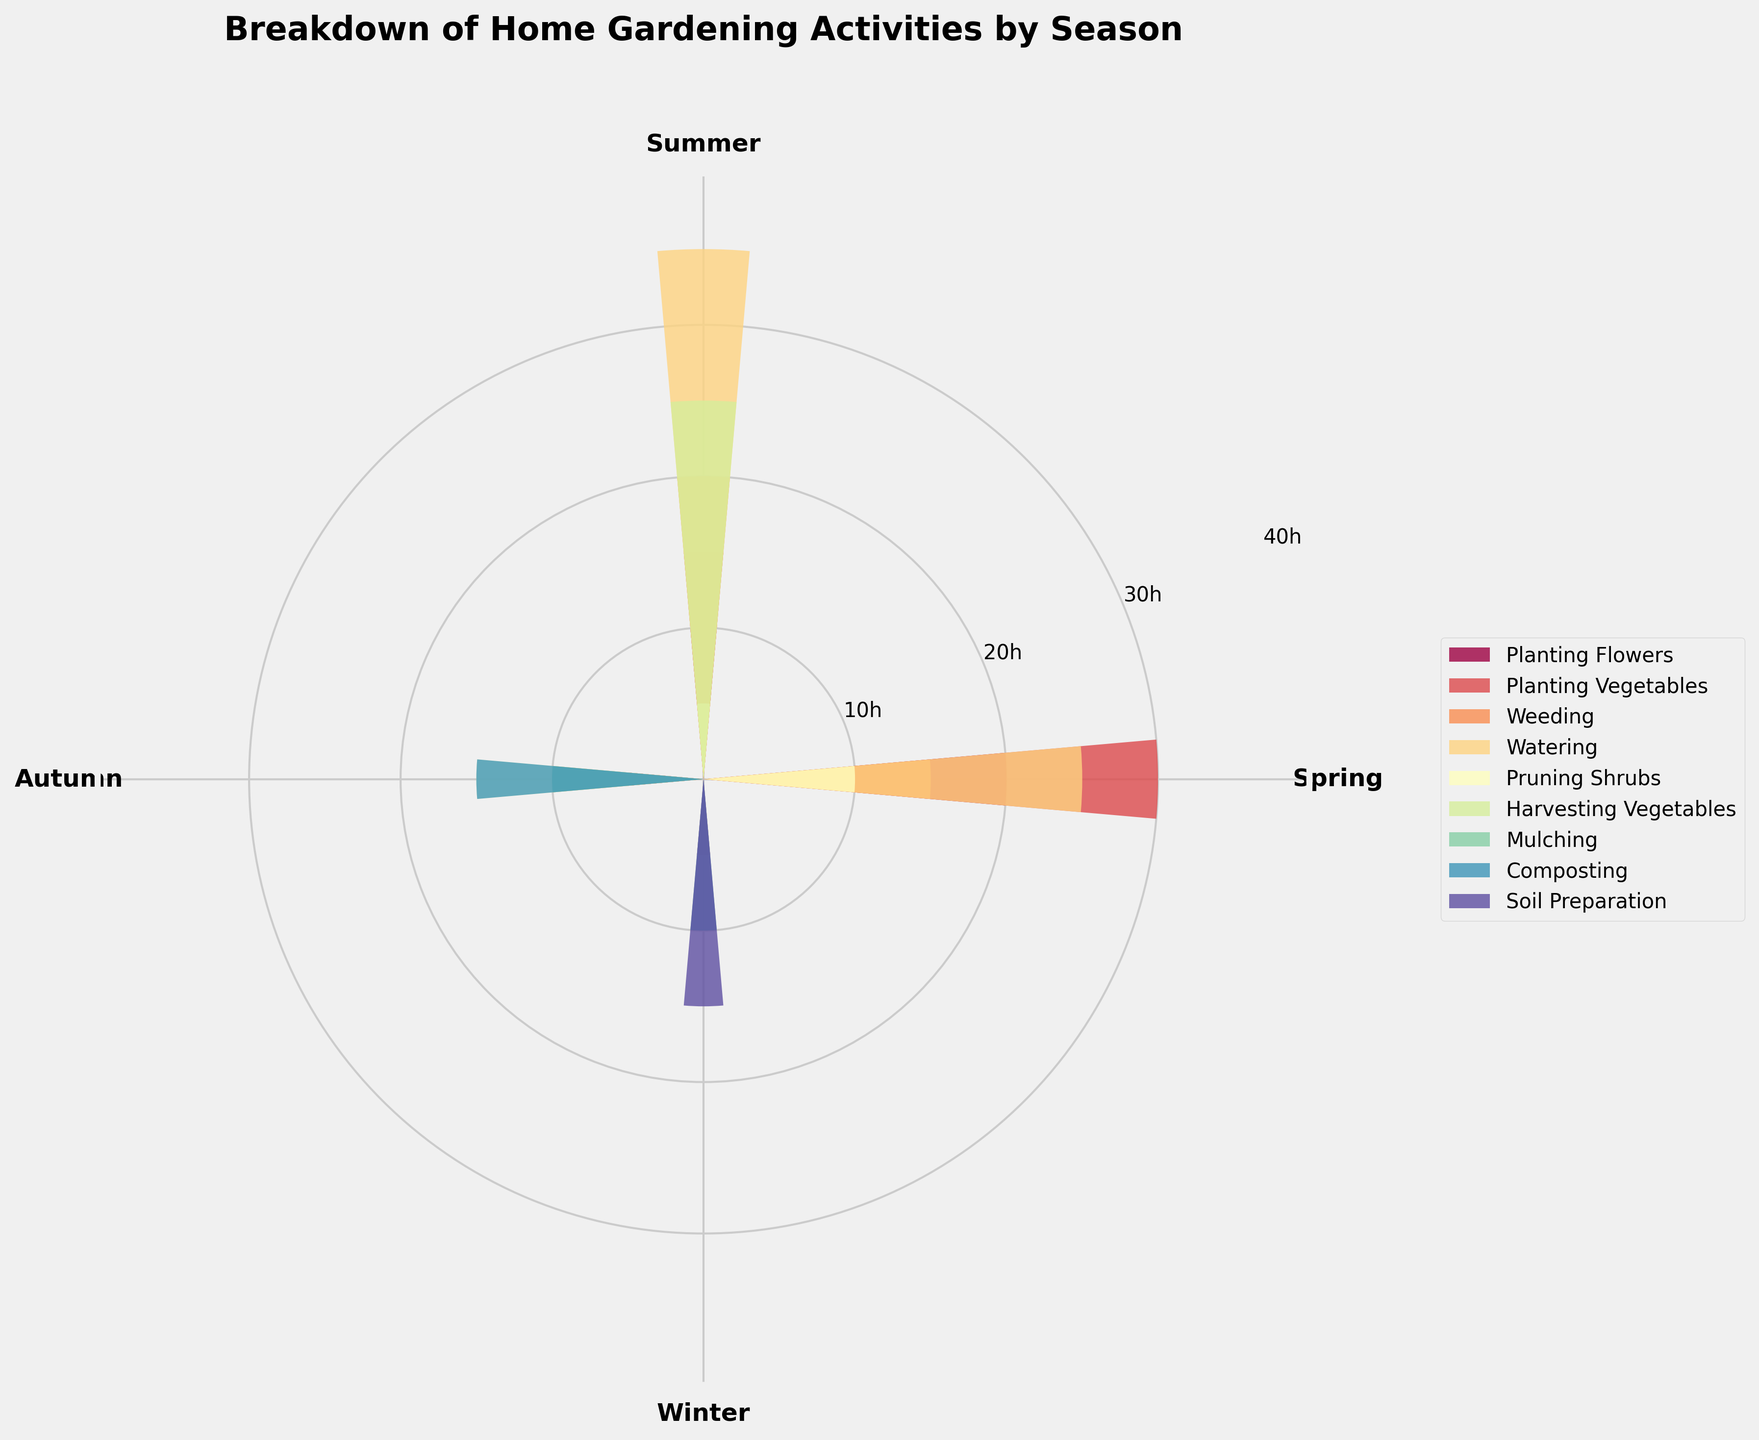What is the title of the chart? The title of the chart is displayed at the top and summarizes the content of the chart.
Answer: Breakdown of Home Gardening Activities by Season Which season has the highest number of hours spent on watering? By looking at the bars related to watering in each season, identify which bar reaches the greatest height.
Answer: Summer How many hours are spent on planting vegetables in spring and autumn combined? Sum the hours spent on planting vegetables in both spring and autumn. Spring: 30, Autumn: 5. 30 + 5 = 35
Answer: 35 Which activity has the least hours during summer? Identify the shortest bar in the summer section to find the activity with the least hours.
Answer: Pruning Shrubs How many activities are performed during winter? Count the number of unique activities listed in the winter section.
Answer: 4 What is the difference in hours spent on weeding between spring and summer? Subtract the hours spent weeding in spring from the hours spent weeding in summer. Spring: 15, Summer: 20. 20 - 15 = 5
Answer: 5 Which activity is exclusive to autumn? Identify any activity that appears only in autumn and not in any other season.
Answer: Mulching and Composting What is the average number of hours spent on planting flowers across all seasons? Sum the hours spent planting flowers in all seasons and then divide by the number of seasons. (Spring: 20, Summer: 10, Autumn: 5, Winter: 5. Total: 40) Average = 40/4 = 10
Answer: 10 In which season is the variety of activities the highest? Count the number of different activities displayed in each season and compare.
Answer: Autumn How many hours in total are spent on pruning shrubs across all seasons? Sum the hours spent on pruning shrubs in all four seasons. (Spring: 10, Summer: 5, Autumn: 15, Winter: 10) Total: 10 + 5 + 15 + 10 = 40
Answer: 40 